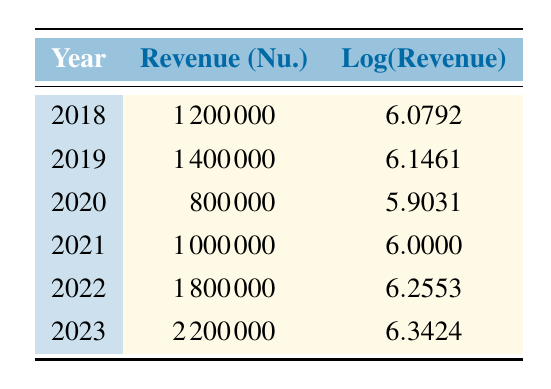What was the revenue for Bhutanese eco-tourism in 2020? According to the table, in 2020, the revenue is specified as 800000.
Answer: 800000 Which year had the highest revenue for eco-tourism? The revenue in 2023 is 2200000, which is greater than all the previous years listed.
Answer: 2023 What is the difference in revenue between 2022 and 2021? For 2022, the revenue is 1800000 and for 2021, it is 1000000. The difference is 1800000 - 1000000 = 800000.
Answer: 800000 Is the revenue in 2019 greater than that in 2021? The revenue for 2019 is 1400000 and for 2021 is 1000000, since 1400000 is greater than 1000000, the statement is true.
Answer: Yes What is the average revenue over the last five years from 2019 to 2023? The revenue from 2019 to 2023 is 1400000 (2019) + 800000 (2020) + 1000000 (2021) + 1800000 (2022) + 2200000 (2023) = 7200000. There are 5 years, so the average is 7200000 / 5 = 1440000.
Answer: 1440000 How much did the revenue increase from 2018 to 2023? The revenue for 2018 is 1200000 and for 2023 is 2200000. The increase is calculated as 2200000 - 1200000 = 1000000.
Answer: 1000000 What is the logarithmic value of the revenue in 2022? The table specifies the logarithmic value of revenue for 2022 as 6.2553.
Answer: 6.2553 In which year did the revenue decrease compared to the previous year? In 2020, the revenue decreased from 1400000 in 2019 to 800000.
Answer: 2020 What is the total revenue from 2018 to 2021? The total revenue from 2018 (1200000) to 2021 (1000000) is 1200000 + 1400000 + 800000 + 1000000 = 4400000.
Answer: 4400000 Is the logarithm of revenue in 2023 greater than that in 2022? The logarithm value for 2023 is 6.3424 and for 2022 is 6.2553; since 6.3424 > 6.2553, the statement is true.
Answer: Yes 